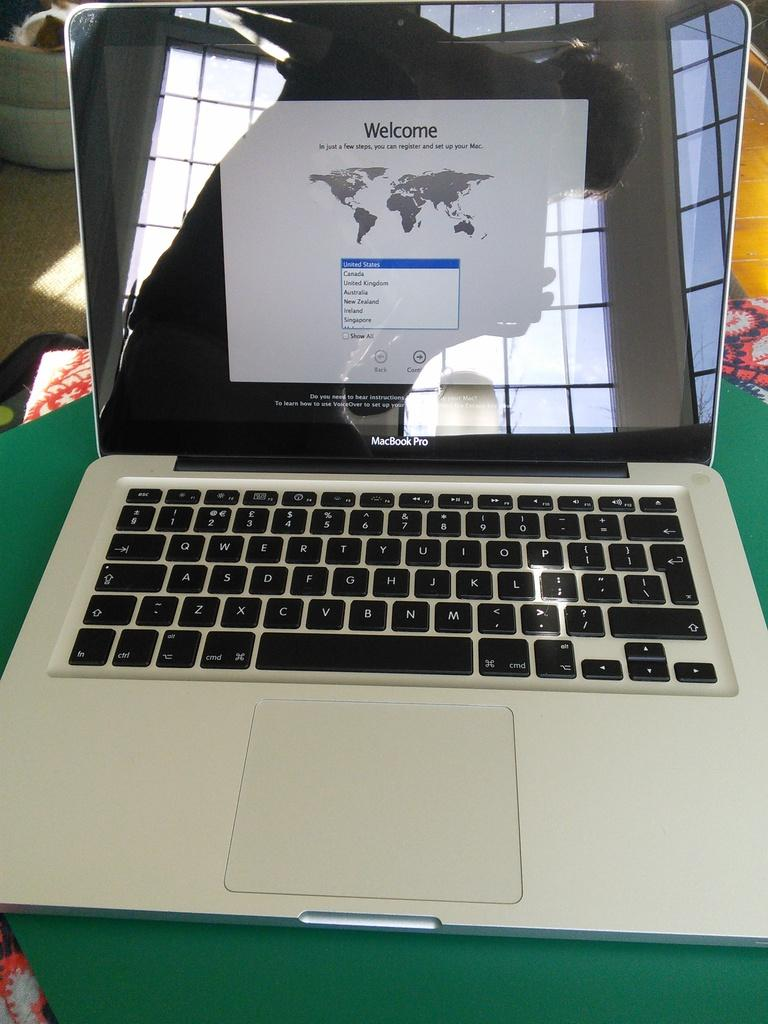<image>
Offer a succinct explanation of the picture presented. An open MacBook Pro with a welcome sign on the screen 